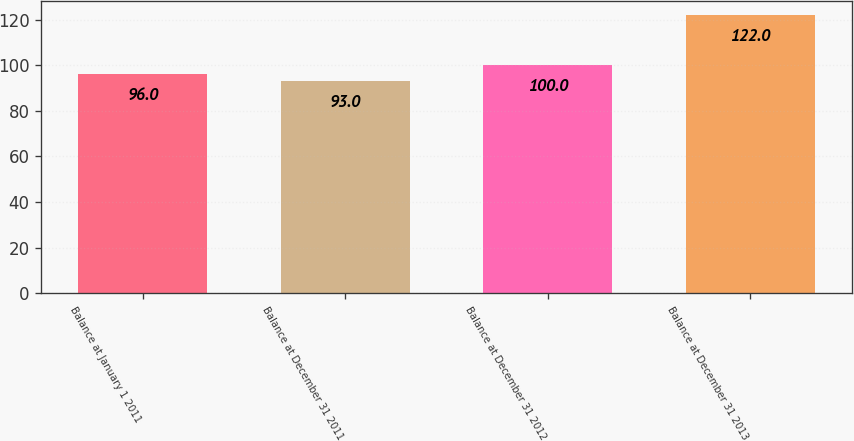Convert chart to OTSL. <chart><loc_0><loc_0><loc_500><loc_500><bar_chart><fcel>Balance at January 1 2011<fcel>Balance at December 31 2011<fcel>Balance at December 31 2012<fcel>Balance at December 31 2013<nl><fcel>96<fcel>93<fcel>100<fcel>122<nl></chart> 